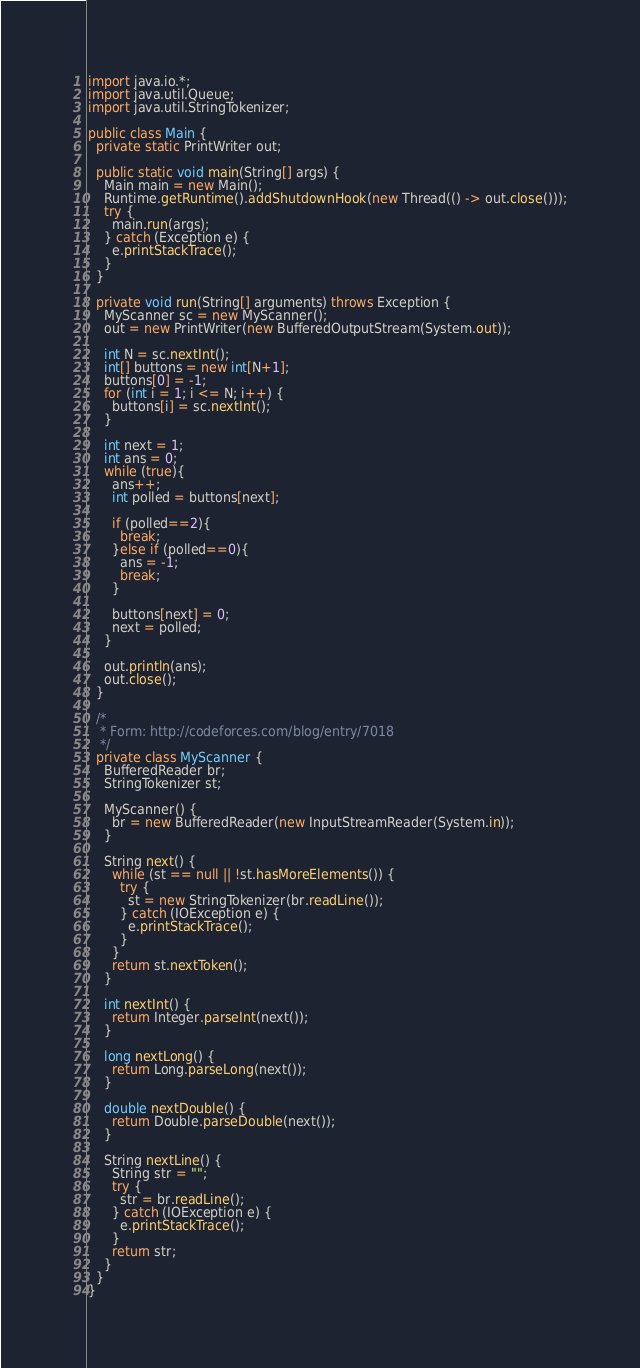<code> <loc_0><loc_0><loc_500><loc_500><_Java_>import java.io.*;
import java.util.Queue;
import java.util.StringTokenizer;

public class Main {
  private static PrintWriter out;

  public static void main(String[] args) {
    Main main = new Main();
    Runtime.getRuntime().addShutdownHook(new Thread(() -> out.close()));
    try {
      main.run(args);
    } catch (Exception e) {
      e.printStackTrace();
    }
  }

  private void run(String[] arguments) throws Exception {
    MyScanner sc = new MyScanner();
    out = new PrintWriter(new BufferedOutputStream(System.out));

    int N = sc.nextInt();
    int[] buttons = new int[N+1];
    buttons[0] = -1;
    for (int i = 1; i <= N; i++) {
      buttons[i] = sc.nextInt();
    }

    int next = 1;
    int ans = 0;
    while (true){
      ans++;
      int polled = buttons[next];

      if (polled==2){
        break;
      }else if (polled==0){
        ans = -1;
        break;
      }

      buttons[next] = 0;
      next = polled;
    }

    out.println(ans);
    out.close();
  }

  /*          
   * Form: http://codeforces.com/blog/entry/7018
   */
  private class MyScanner {
    BufferedReader br;
    StringTokenizer st;

    MyScanner() {
      br = new BufferedReader(new InputStreamReader(System.in));
    }

    String next() {
      while (st == null || !st.hasMoreElements()) {
        try {
          st = new StringTokenizer(br.readLine());
        } catch (IOException e) {
          e.printStackTrace();
        }
      }
      return st.nextToken();
    }

    int nextInt() {
      return Integer.parseInt(next());
    }

    long nextLong() {
      return Long.parseLong(next());
    }

    double nextDouble() {
      return Double.parseDouble(next());
    }

    String nextLine() {
      String str = "";
      try {
        str = br.readLine();
      } catch (IOException e) {
        e.printStackTrace();
      }
      return str;
    }
  }
}
</code> 